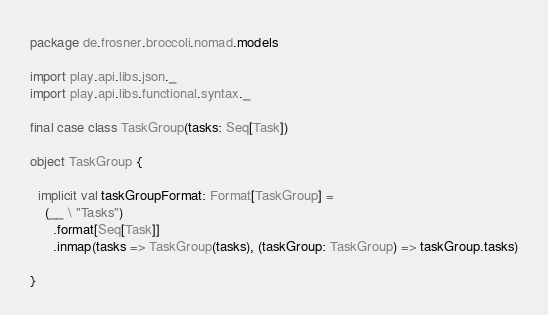<code> <loc_0><loc_0><loc_500><loc_500><_Scala_>package de.frosner.broccoli.nomad.models

import play.api.libs.json._
import play.api.libs.functional.syntax._

final case class TaskGroup(tasks: Seq[Task])

object TaskGroup {

  implicit val taskGroupFormat: Format[TaskGroup] =
    (__ \ "Tasks")
      .format[Seq[Task]]
      .inmap(tasks => TaskGroup(tasks), (taskGroup: TaskGroup) => taskGroup.tasks)

}
</code> 